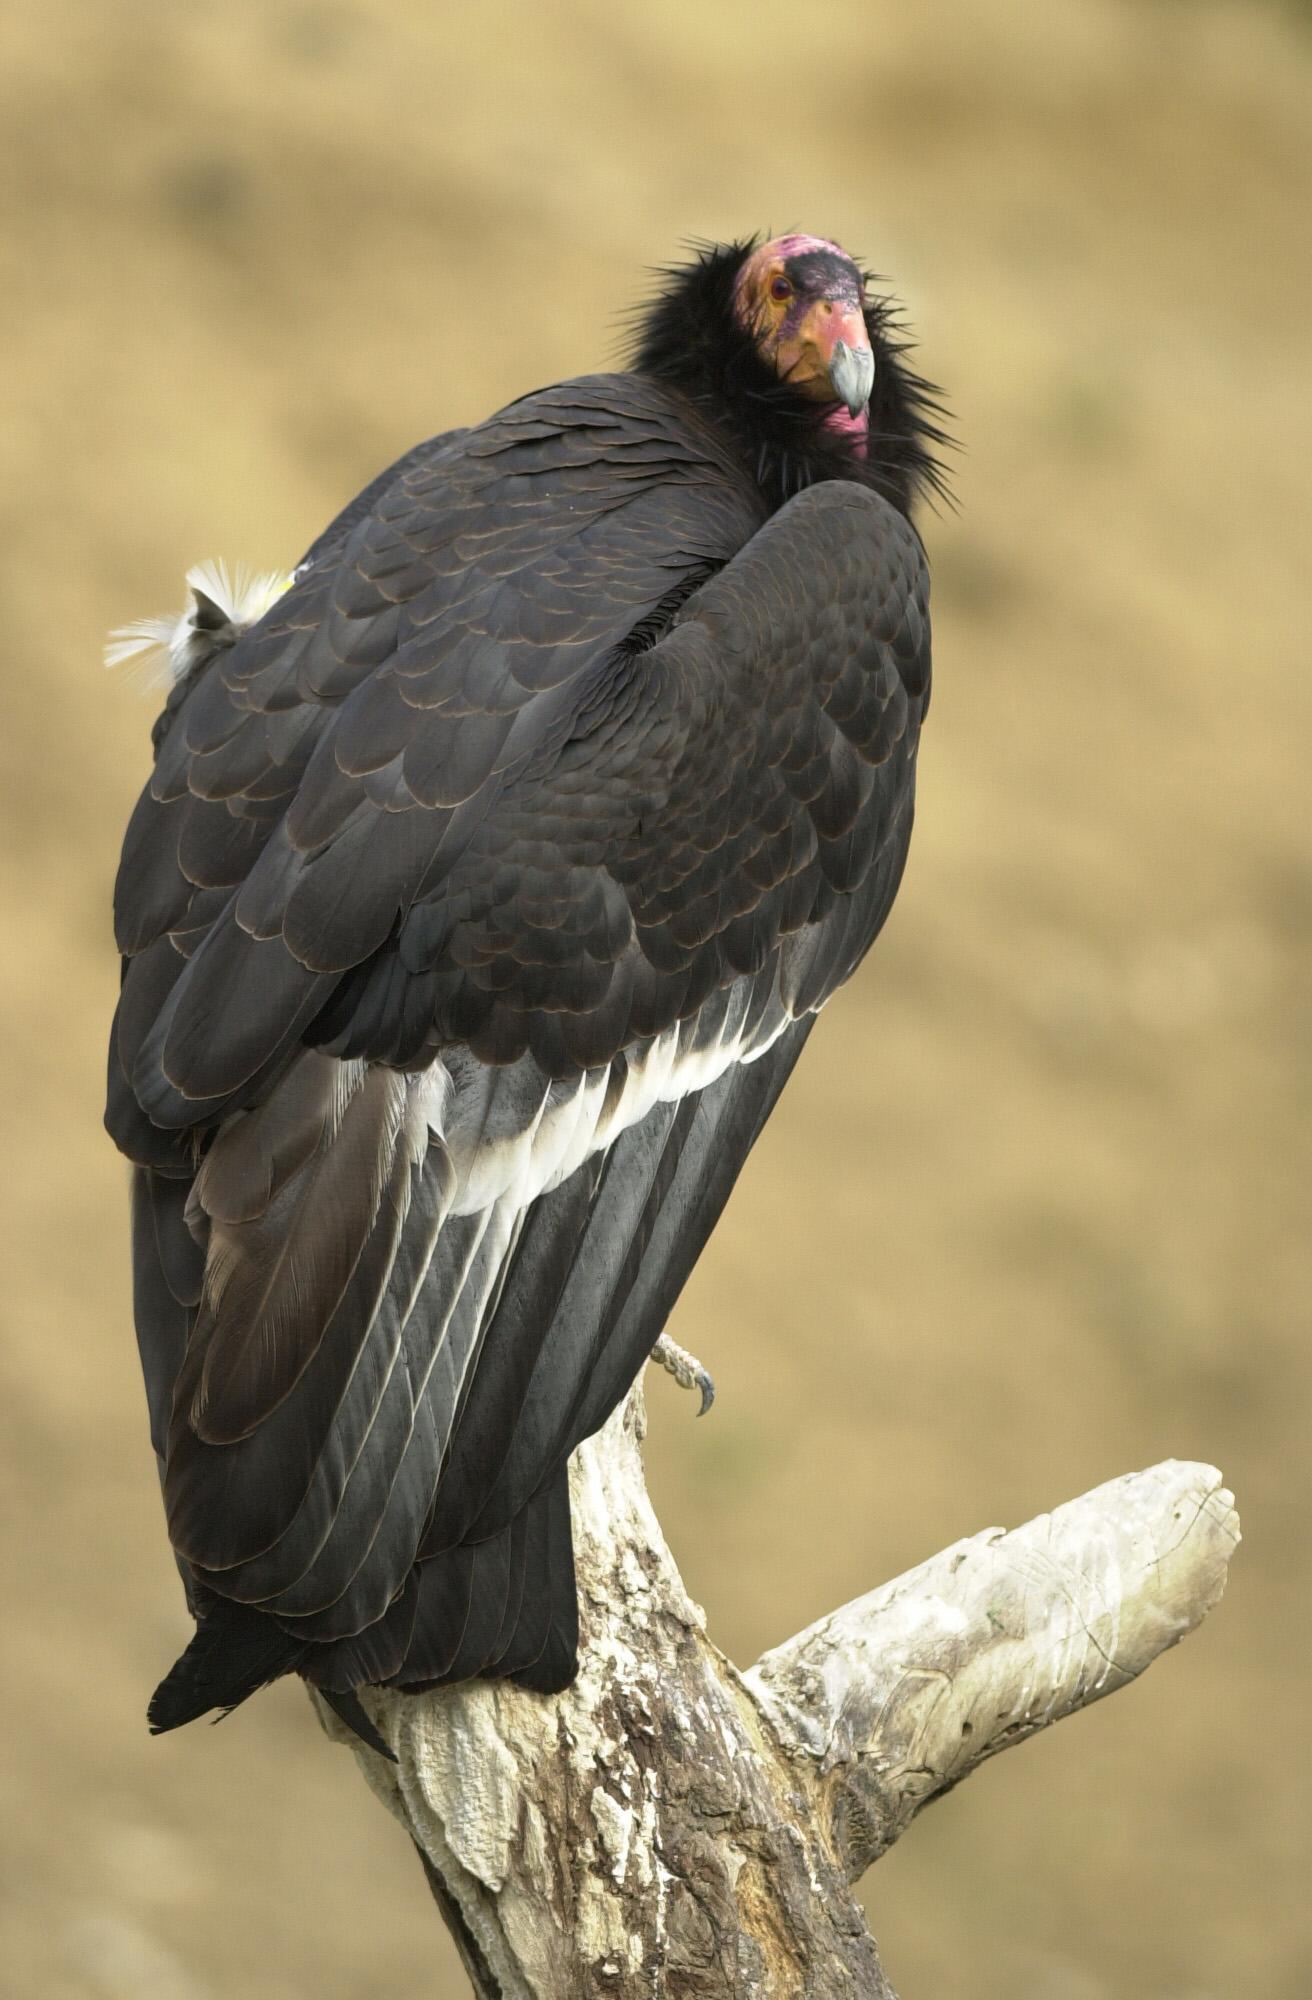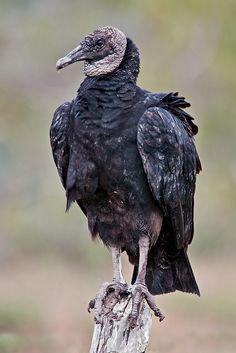The first image is the image on the left, the second image is the image on the right. Evaluate the accuracy of this statement regarding the images: "In the pair, one bird is standing on a post and the other on a flat surface.". Is it true? Answer yes or no. No. 